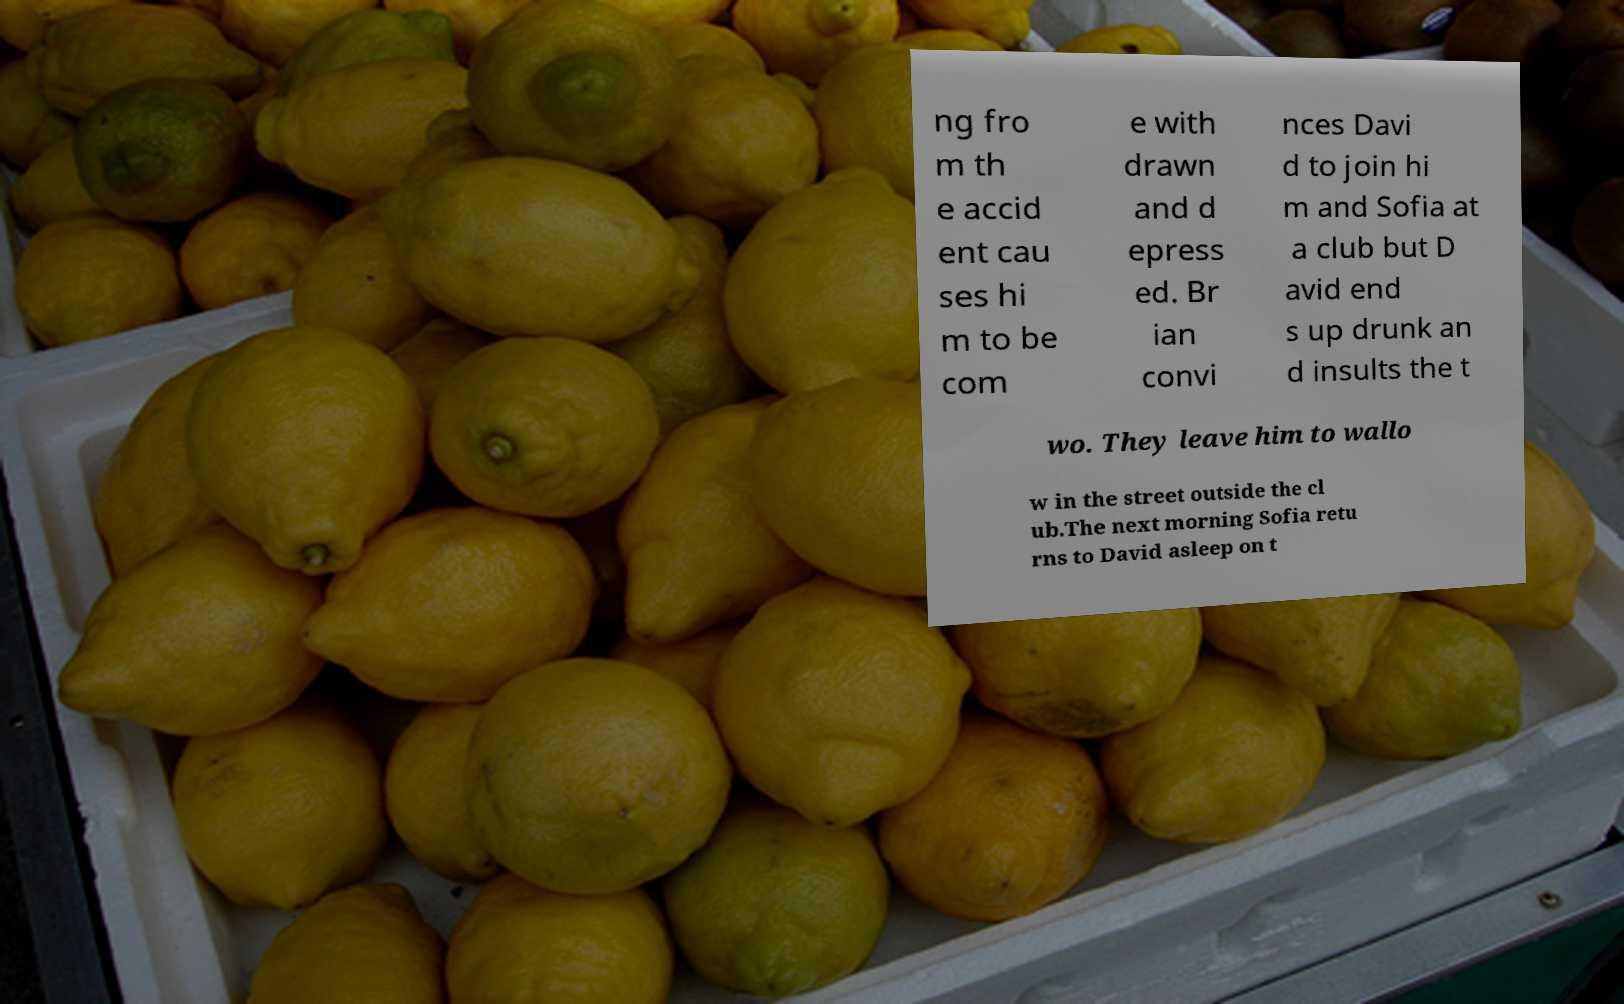What messages or text are displayed in this image? I need them in a readable, typed format. ng fro m th e accid ent cau ses hi m to be com e with drawn and d epress ed. Br ian convi nces Davi d to join hi m and Sofia at a club but D avid end s up drunk an d insults the t wo. They leave him to wallo w in the street outside the cl ub.The next morning Sofia retu rns to David asleep on t 